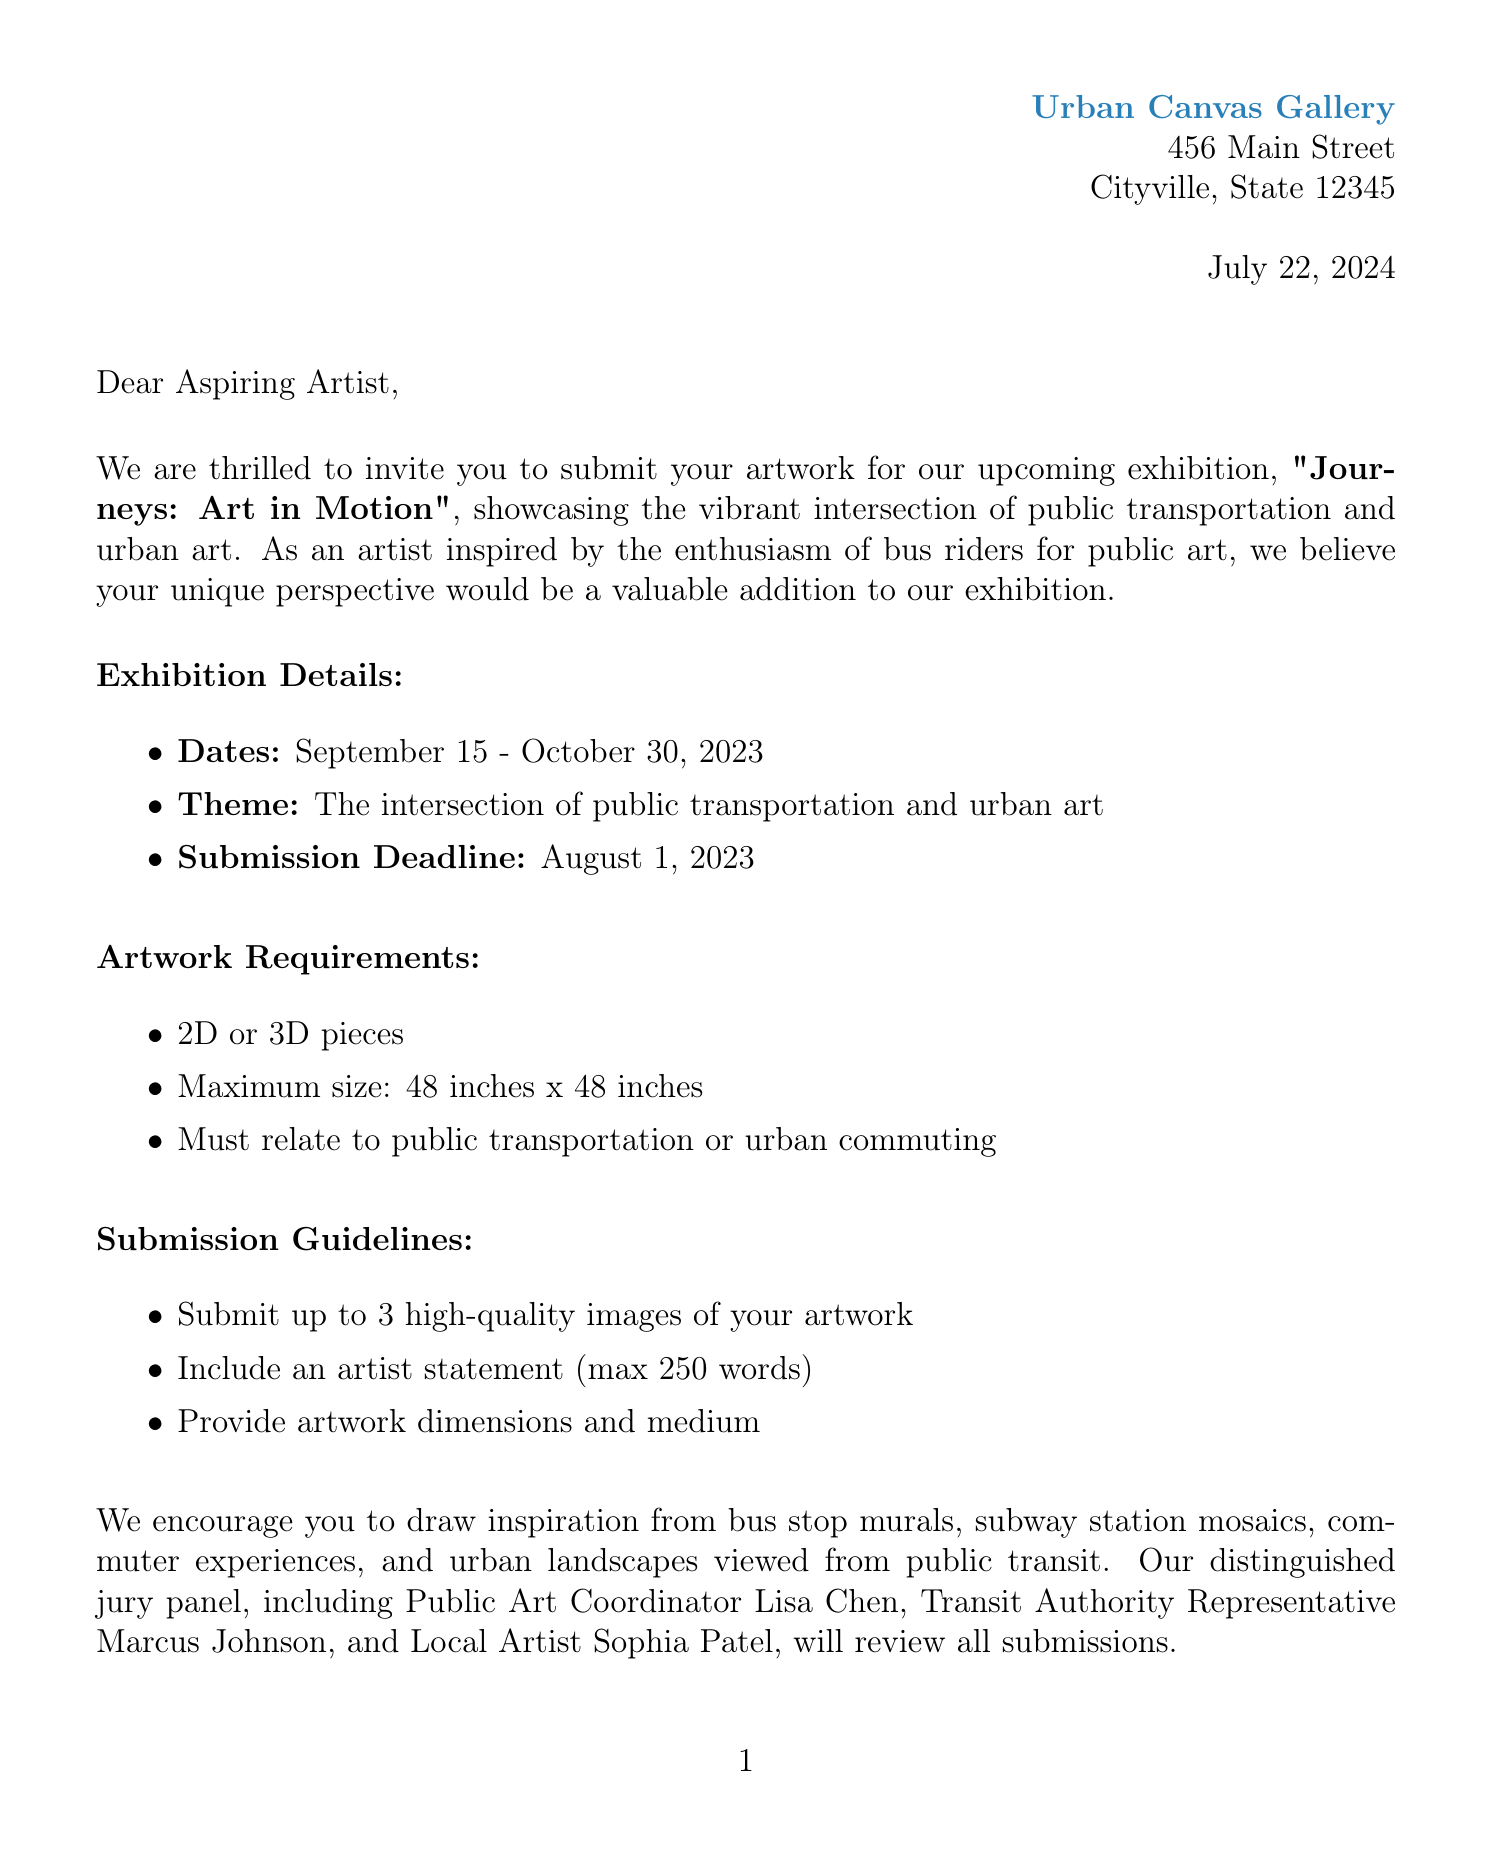What is the title of the exhibition? The title of the exhibition is explicitly mentioned in the letter as "Journeys: Art in Motion."
Answer: Journeys: Art in Motion What is the submission deadline? The submission deadline is clearly stated in the document as August 1, 2023.
Answer: August 1, 2023 Who is the contact person for submissions? The contact person for submissions is listed in the letter as Emma Rodriguez.
Answer: Emma Rodriguez What are the first place prizes? The first place prize details are mentioned in terms of monetary value and opportunity as $1,000 and a solo exhibition.
Answer: $1,000 and a solo exhibition What is the maximum size for artwork submissions? The maximum size for artwork submissions is specified as 48 inches x 48 inches.
Answer: 48 inches x 48 inches How many images can be submitted? The submission guidelines indicate that up to 3 high-quality images of artwork can be submitted.
Answer: 3 What theme should the artwork relate to? The theme that the artwork must relate to is the intersection of public transportation and urban art.
Answer: Public transportation and urban art Where will selected artworks be displayed after the exhibition? The document states that selected artworks will be displayed on city buses for one month following the exhibition.
Answer: City buses Who is part of the jury panel? The jury panel consists of Lisa Chen, Marcus Johnson, and Sophia Patel as listed in the document.
Answer: Lisa Chen, Marcus Johnson, Sophia Patel 